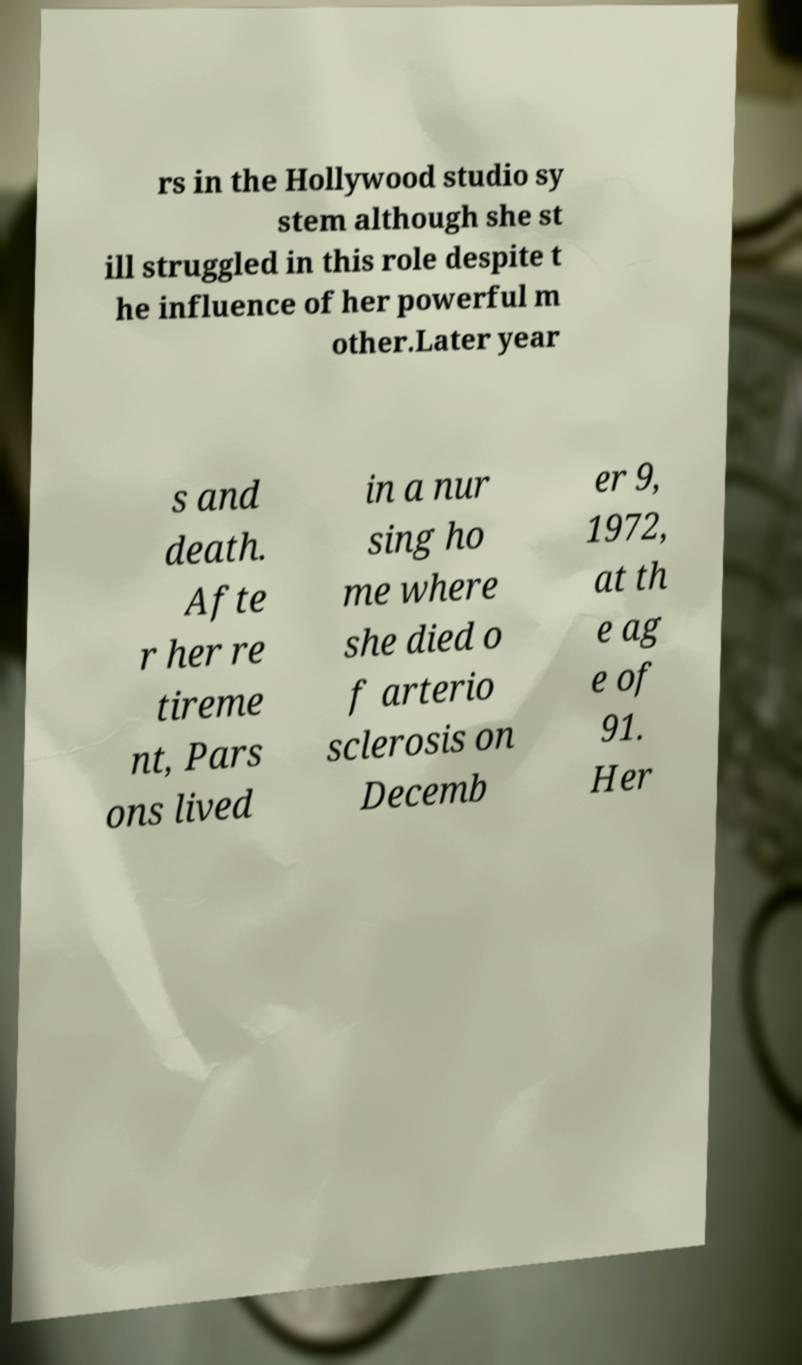Could you assist in decoding the text presented in this image and type it out clearly? rs in the Hollywood studio sy stem although she st ill struggled in this role despite t he influence of her powerful m other.Later year s and death. Afte r her re tireme nt, Pars ons lived in a nur sing ho me where she died o f arterio sclerosis on Decemb er 9, 1972, at th e ag e of 91. Her 